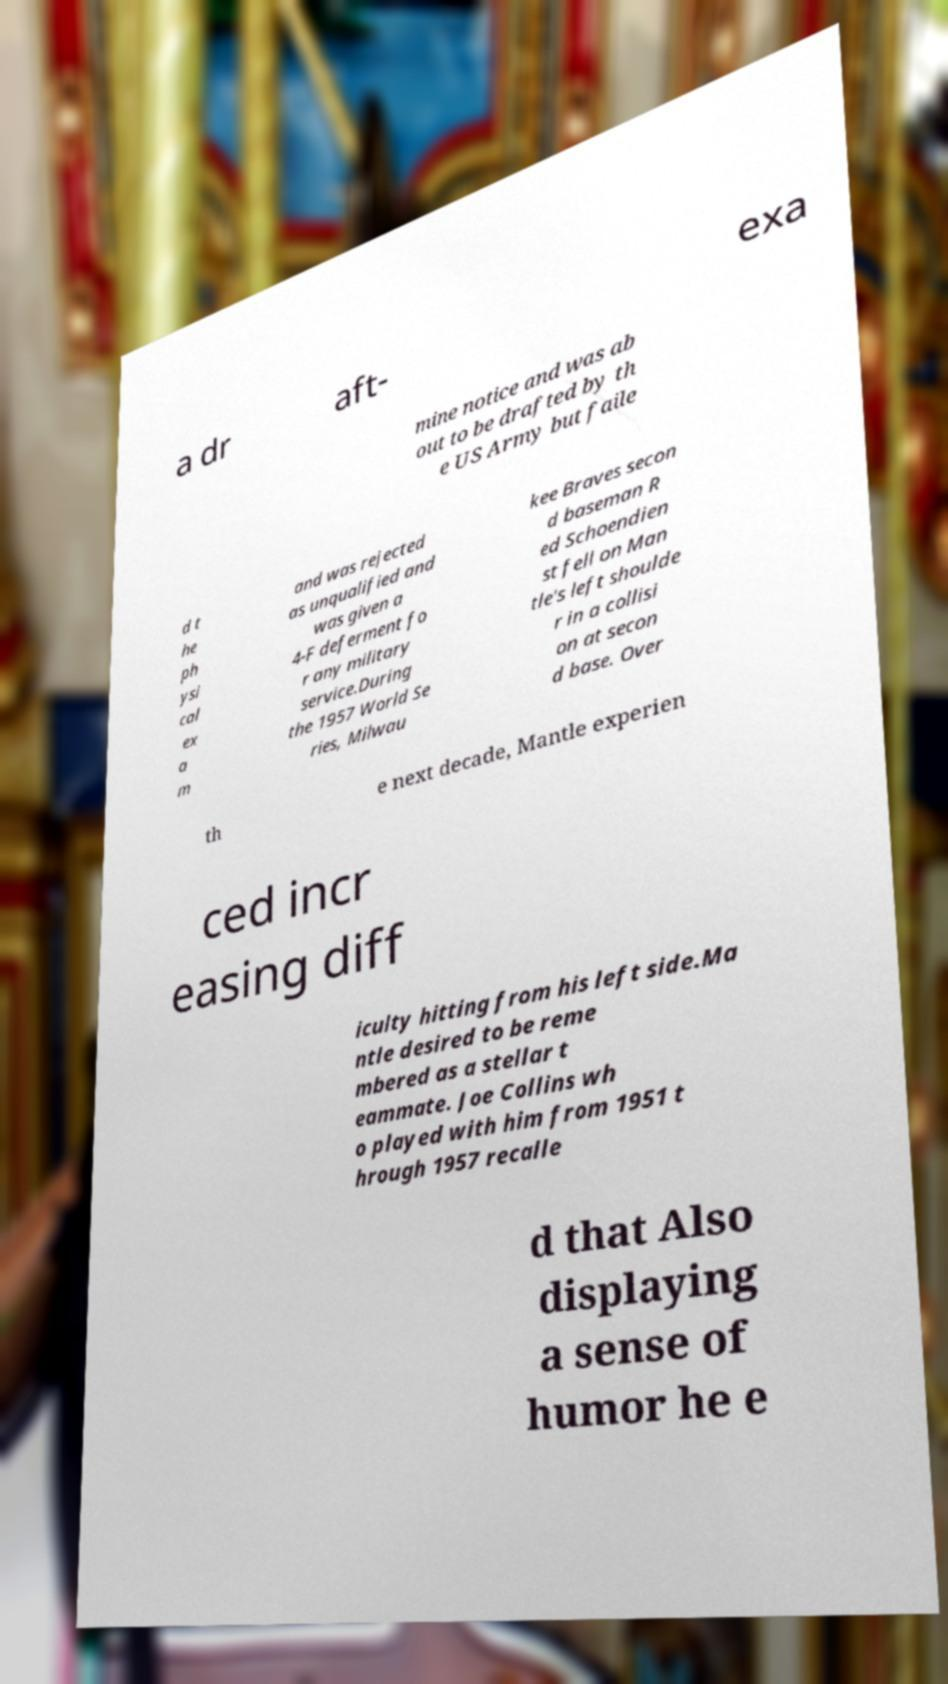I need the written content from this picture converted into text. Can you do that? a dr aft- exa mine notice and was ab out to be drafted by th e US Army but faile d t he ph ysi cal ex a m and was rejected as unqualified and was given a 4-F deferment fo r any military service.During the 1957 World Se ries, Milwau kee Braves secon d baseman R ed Schoendien st fell on Man tle's left shoulde r in a collisi on at secon d base. Over th e next decade, Mantle experien ced incr easing diff iculty hitting from his left side.Ma ntle desired to be reme mbered as a stellar t eammate. Joe Collins wh o played with him from 1951 t hrough 1957 recalle d that Also displaying a sense of humor he e 